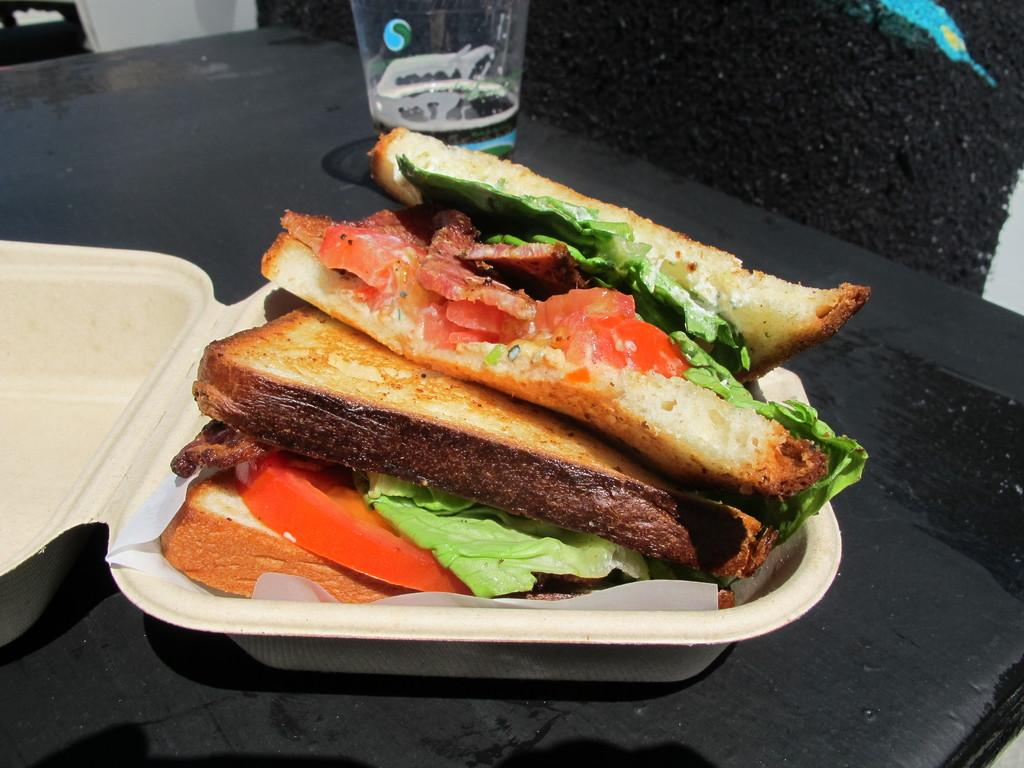What color is the table in the image? The table in the image is black. What type of food can be seen on the table? There are sandwiches in a box on the table. What else is on the table besides the sandwiches? There is a glass on the table. What type of skin is visible on the table in the image? There is no skin visible on the table in the image; it is a black table with objects on it. 